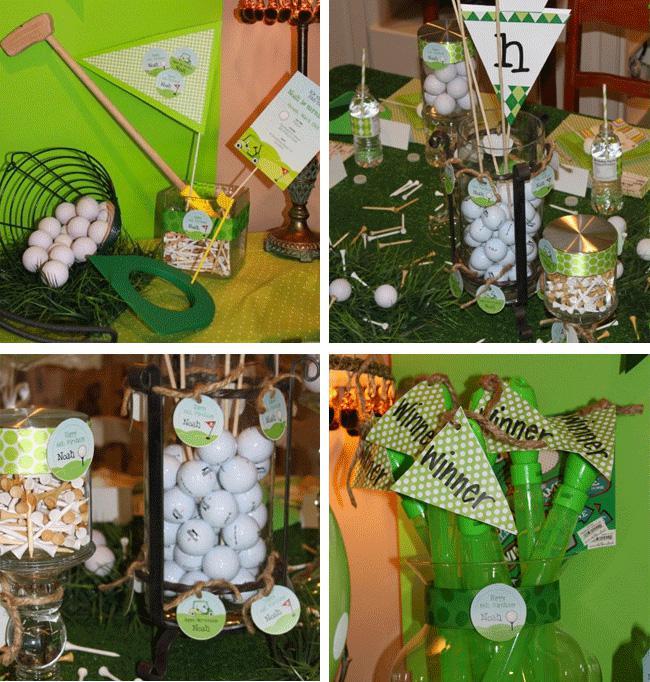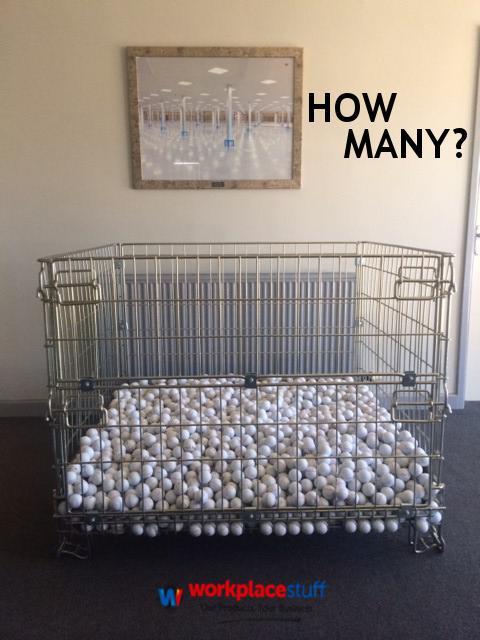The first image is the image on the left, the second image is the image on the right. Analyze the images presented: Is the assertion "Some of the balls are in a clear container in one of the images." valid? Answer yes or no. Yes. The first image is the image on the left, the second image is the image on the right. Given the left and right images, does the statement "A pile of used golf balls includes at least one pink and one yellow ball." hold true? Answer yes or no. No. 